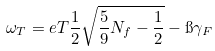Convert formula to latex. <formula><loc_0><loc_0><loc_500><loc_500>\omega _ { T } = e T \frac { 1 } { 2 } \sqrt { \frac { 5 } { 9 } N _ { f } - \frac { 1 } { 2 } } - \i \gamma _ { F }</formula> 